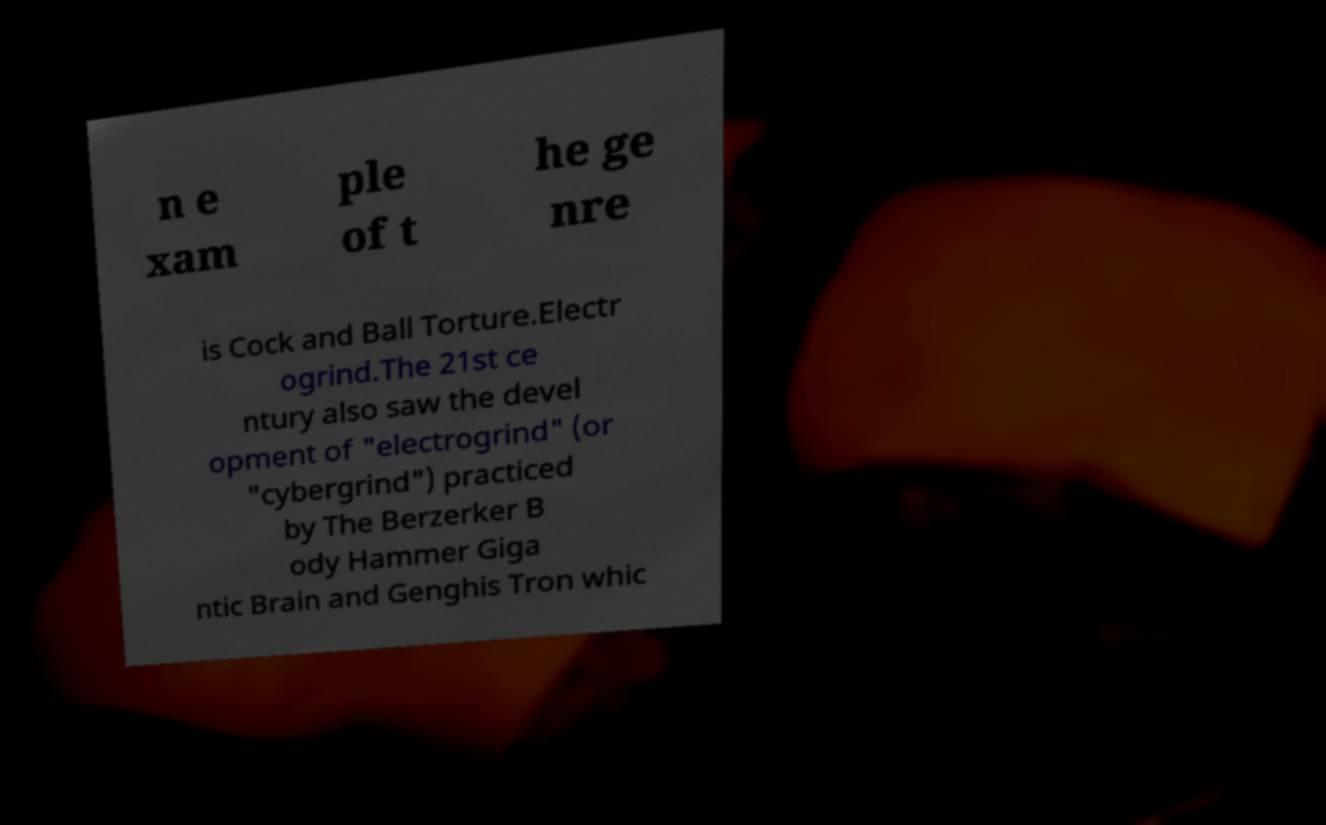Can you accurately transcribe the text from the provided image for me? n e xam ple of t he ge nre is Cock and Ball Torture.Electr ogrind.The 21st ce ntury also saw the devel opment of "electrogrind" (or "cybergrind") practiced by The Berzerker B ody Hammer Giga ntic Brain and Genghis Tron whic 